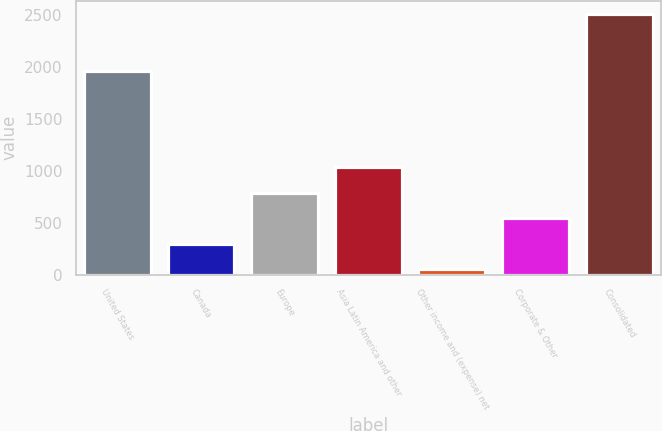Convert chart. <chart><loc_0><loc_0><loc_500><loc_500><bar_chart><fcel>United States<fcel>Canada<fcel>Europe<fcel>Asia Latin America and other<fcel>Other income and (expense) net<fcel>Corporate & Other<fcel>Consolidated<nl><fcel>1953.1<fcel>296.72<fcel>787.76<fcel>1033.28<fcel>51.2<fcel>542.24<fcel>2506.4<nl></chart> 